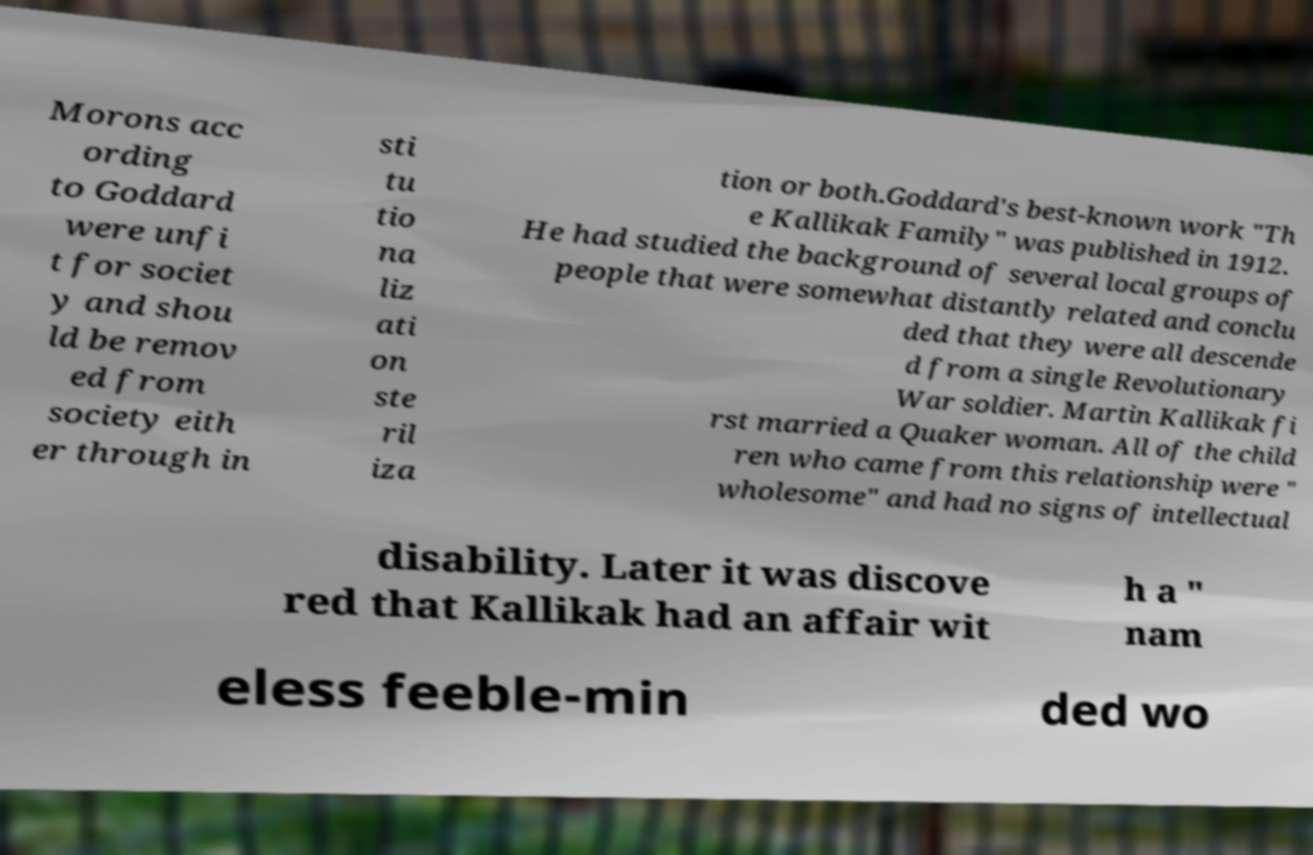Could you extract and type out the text from this image? Morons acc ording to Goddard were unfi t for societ y and shou ld be remov ed from society eith er through in sti tu tio na liz ati on ste ril iza tion or both.Goddard's best-known work "Th e Kallikak Family" was published in 1912. He had studied the background of several local groups of people that were somewhat distantly related and conclu ded that they were all descende d from a single Revolutionary War soldier. Martin Kallikak fi rst married a Quaker woman. All of the child ren who came from this relationship were " wholesome" and had no signs of intellectual disability. Later it was discove red that Kallikak had an affair wit h a " nam eless feeble-min ded wo 